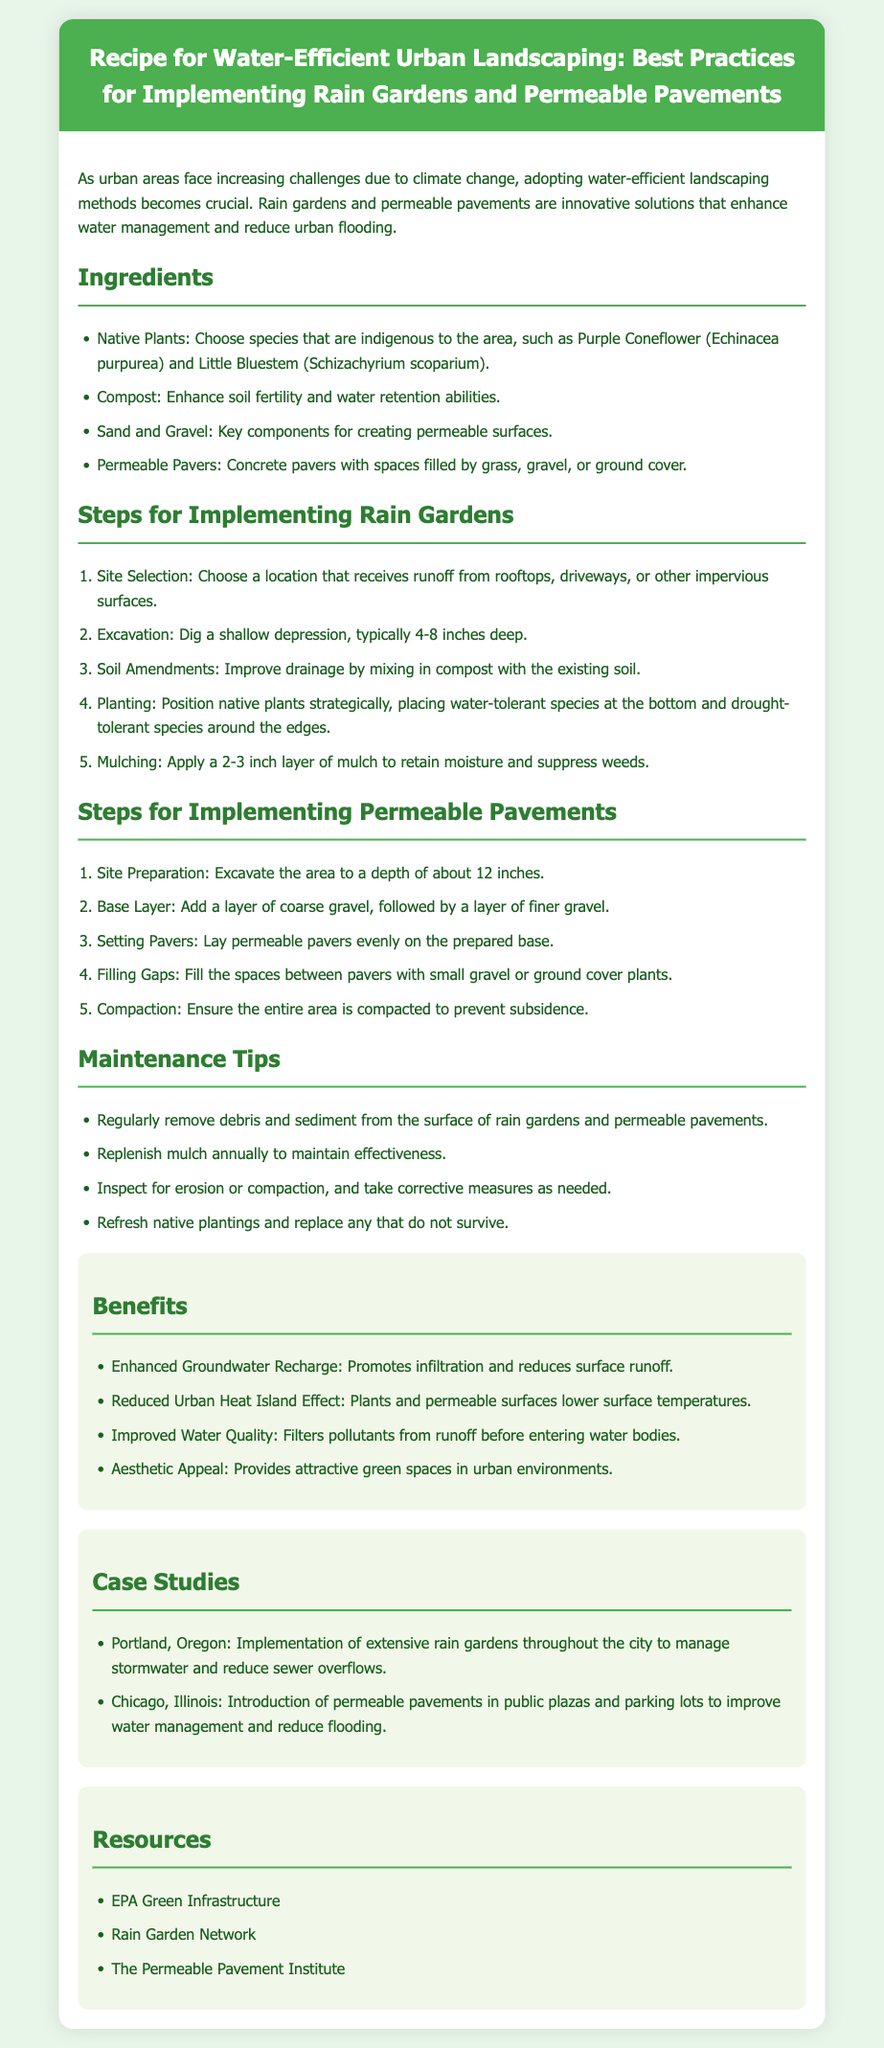What are two examples of native plants? The document lists native plants as examples such as Purple Coneflower and Little Bluestem.
Answer: Purple Coneflower, Little Bluestem How deep should the excavation for a rain garden be? The recommended depth for excavation when implementing a rain garden is specified to be 4-8 inches deep.
Answer: 4-8 inches What is the purpose of using compost in the rain garden? Compost enhances soil fertility and water retention abilities, as mentioned in the ingredients section.
Answer: Soil fertility and water retention What is a key component needed for permeable surfaces? The document mentions sand and gravel as key components for creating permeable surfaces.
Answer: Sand and gravel Which city implemented extensive rain gardens to manage stormwater? The case studies mention Portland, Oregon, as a city that implemented extensive rain gardens.
Answer: Portland, Oregon What layer is added first when preparing for permeable pavements? In the steps for implementing permeable pavements, a layer of coarse gravel is specified to be added first.
Answer: Coarse gravel How often should mulch be replenished in a rain garden? The maintenance tips indicate that mulch should be replenished annually.
Answer: Annually What is one benefit of using permeable pavements? The benefits section highlights that permeable pavements improve water quality.
Answer: Improve water quality 